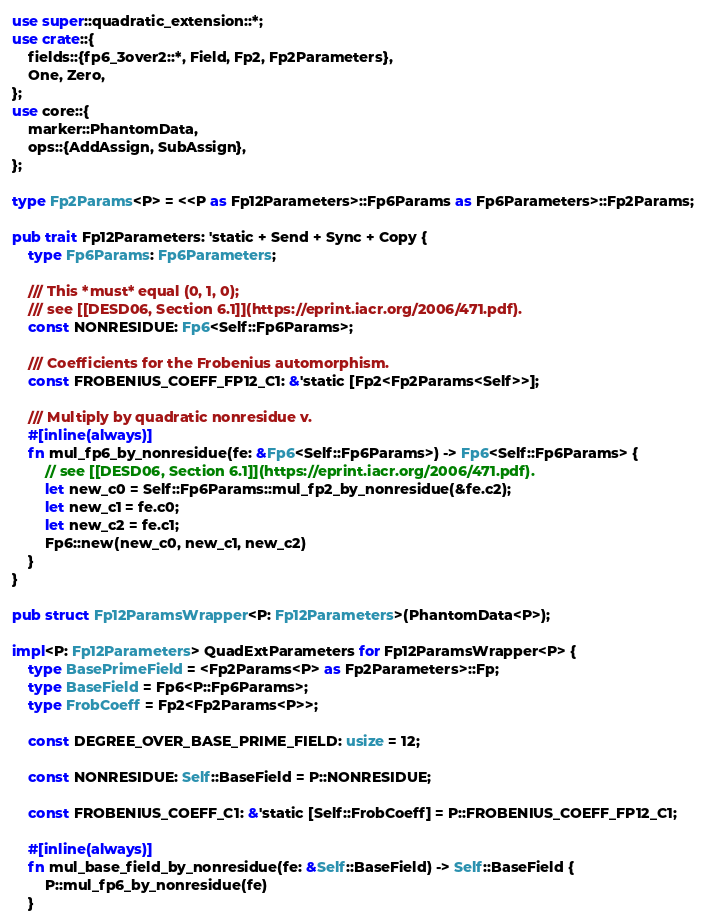<code> <loc_0><loc_0><loc_500><loc_500><_Rust_>use super::quadratic_extension::*;
use crate::{
    fields::{fp6_3over2::*, Field, Fp2, Fp2Parameters},
    One, Zero,
};
use core::{
    marker::PhantomData,
    ops::{AddAssign, SubAssign},
};

type Fp2Params<P> = <<P as Fp12Parameters>::Fp6Params as Fp6Parameters>::Fp2Params;

pub trait Fp12Parameters: 'static + Send + Sync + Copy {
    type Fp6Params: Fp6Parameters;

    /// This *must* equal (0, 1, 0);
    /// see [[DESD06, Section 6.1]](https://eprint.iacr.org/2006/471.pdf).
    const NONRESIDUE: Fp6<Self::Fp6Params>;

    /// Coefficients for the Frobenius automorphism.
    const FROBENIUS_COEFF_FP12_C1: &'static [Fp2<Fp2Params<Self>>];

    /// Multiply by quadratic nonresidue v.
    #[inline(always)]
    fn mul_fp6_by_nonresidue(fe: &Fp6<Self::Fp6Params>) -> Fp6<Self::Fp6Params> {
        // see [[DESD06, Section 6.1]](https://eprint.iacr.org/2006/471.pdf).
        let new_c0 = Self::Fp6Params::mul_fp2_by_nonresidue(&fe.c2);
        let new_c1 = fe.c0;
        let new_c2 = fe.c1;
        Fp6::new(new_c0, new_c1, new_c2)
    }
}

pub struct Fp12ParamsWrapper<P: Fp12Parameters>(PhantomData<P>);

impl<P: Fp12Parameters> QuadExtParameters for Fp12ParamsWrapper<P> {
    type BasePrimeField = <Fp2Params<P> as Fp2Parameters>::Fp;
    type BaseField = Fp6<P::Fp6Params>;
    type FrobCoeff = Fp2<Fp2Params<P>>;

    const DEGREE_OVER_BASE_PRIME_FIELD: usize = 12;

    const NONRESIDUE: Self::BaseField = P::NONRESIDUE;

    const FROBENIUS_COEFF_C1: &'static [Self::FrobCoeff] = P::FROBENIUS_COEFF_FP12_C1;

    #[inline(always)]
    fn mul_base_field_by_nonresidue(fe: &Self::BaseField) -> Self::BaseField {
        P::mul_fp6_by_nonresidue(fe)
    }
</code> 